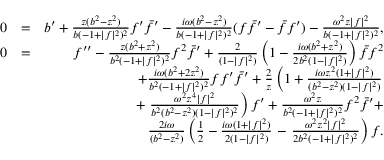<formula> <loc_0><loc_0><loc_500><loc_500>\begin{array} { r l r } { 0 } & { = } & { b ^ { \prime } + { \frac { z ( b ^ { 2 } - z ^ { 2 } ) } { b ( - 1 + | f | ^ { 2 } ) ^ { 2 } } } f ^ { \prime } \bar { f } ^ { \prime } - { \frac { i \omega ( b ^ { 2 } - z ^ { 2 } ) } { b ( - 1 + | f | ^ { 2 } ) ^ { 2 } } } ( f \bar { f } ^ { \prime } - \bar { f } f ^ { \prime } ) - { \frac { \omega ^ { 2 } z | f | ^ { 2 } } { b ( - 1 + | f | ^ { 2 } ) ^ { 2 } } } , } \\ { 0 } & { = } & { f ^ { \prime \prime } - { \frac { z ( b ^ { 2 } + z ^ { 2 } ) } { b ^ { 2 } ( - 1 + | f | ^ { 2 } ) ^ { 2 } } } f ^ { 2 } \bar { f } ^ { \prime } + { \frac { 2 } { ( 1 - | f | ^ { 2 } ) } } \left ( 1 - { \frac { i \omega ( b ^ { 2 } + z ^ { 2 } ) } { 2 b ^ { 2 } ( 1 - | f | ^ { 2 } ) } } \right ) \bar { f } f ^ { 2 } } \\ & { + { \frac { i \omega ( b ^ { 2 } + 2 z ^ { 2 } ) } { b ^ { 2 } ( - 1 + | f | ^ { 2 } ) ^ { 2 } } } f f ^ { \prime } \bar { f } ^ { \prime } + { \frac { 2 } { z } } \left ( 1 + { \frac { i \omega z ^ { 2 } ( 1 + | f | ^ { 2 } ) } { ( b ^ { 2 } - z ^ { 2 } ) ( 1 - | f | ^ { 2 } ) } } } \\ & { + { \frac { \omega ^ { 2 } z ^ { 4 } | f | ^ { 2 } } { b ^ { 2 } ( b ^ { 2 } - z ^ { 2 } ) ( 1 - | f | ^ { 2 } ) ^ { 2 } } } \right ) f ^ { \prime } + { \frac { \omega ^ { 2 } z } { b ^ { 2 } ( - 1 + | f | ^ { 2 } ) ^ { 2 } } } f ^ { 2 } \bar { f } ^ { \prime } + } \\ & { { \frac { 2 i \omega } { ( b ^ { 2 } - z ^ { 2 } ) } } \left ( \frac { 1 } { 2 } - { \frac { i \omega ( 1 + | f | ^ { 2 } ) } { 2 ( 1 - | f | ^ { 2 } ) } } - { \frac { \omega ^ { 2 } z ^ { 2 } | f | ^ { 2 } } { 2 b ^ { 2 } ( - 1 + | f | ^ { 2 } ) ^ { 2 } } } \right ) f . } \end{array}</formula> 